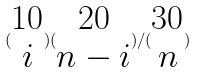<formula> <loc_0><loc_0><loc_500><loc_500>( \begin{matrix} 1 0 \\ i \end{matrix} ) ( \begin{matrix} 2 0 \\ n - i \end{matrix} ) / ( \begin{matrix} 3 0 \\ n \end{matrix} )</formula> 